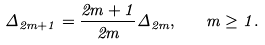Convert formula to latex. <formula><loc_0><loc_0><loc_500><loc_500>\Delta _ { 2 m + 1 } = \frac { 2 m + 1 } { 2 m } \Delta _ { 2 m } , \quad m \geq 1 .</formula> 